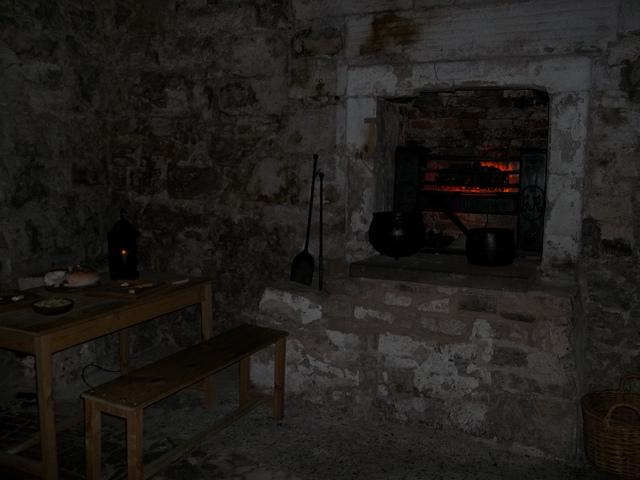What type of heat is shown? Please explain your reasoning. fire. The only heat producing feature of this picture is the fire in the fireplace we can see glowing orange here. 